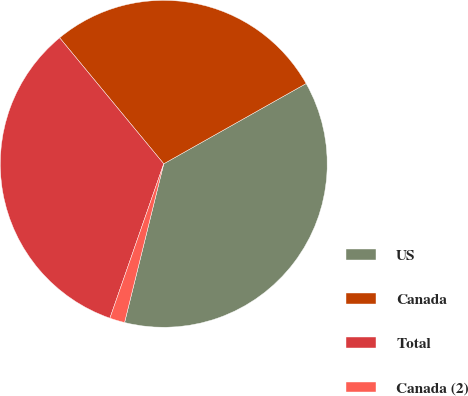<chart> <loc_0><loc_0><loc_500><loc_500><pie_chart><fcel>US<fcel>Canada<fcel>Total<fcel>Canada (2)<nl><fcel>37.02%<fcel>27.82%<fcel>33.67%<fcel>1.49%<nl></chart> 